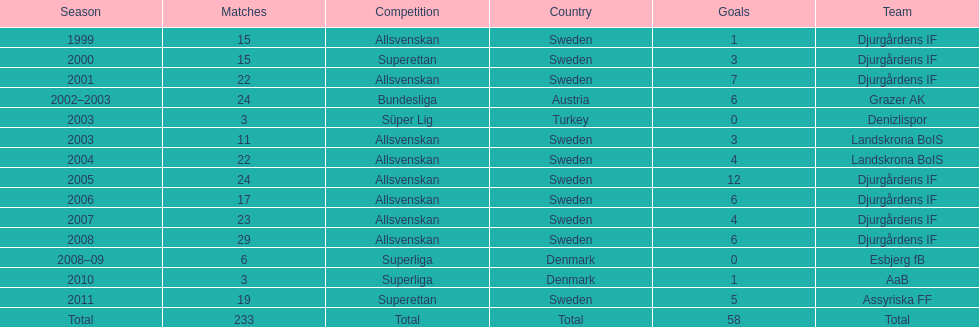What season has the most goals? 2005. 